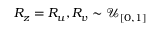<formula> <loc_0><loc_0><loc_500><loc_500>R _ { z } = R _ { u } , R _ { v } \sim \mathcal { U } _ { [ 0 , 1 ] }</formula> 